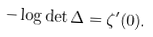Convert formula to latex. <formula><loc_0><loc_0><loc_500><loc_500>- \log \det \Delta = \zeta ^ { \prime } ( 0 ) .</formula> 